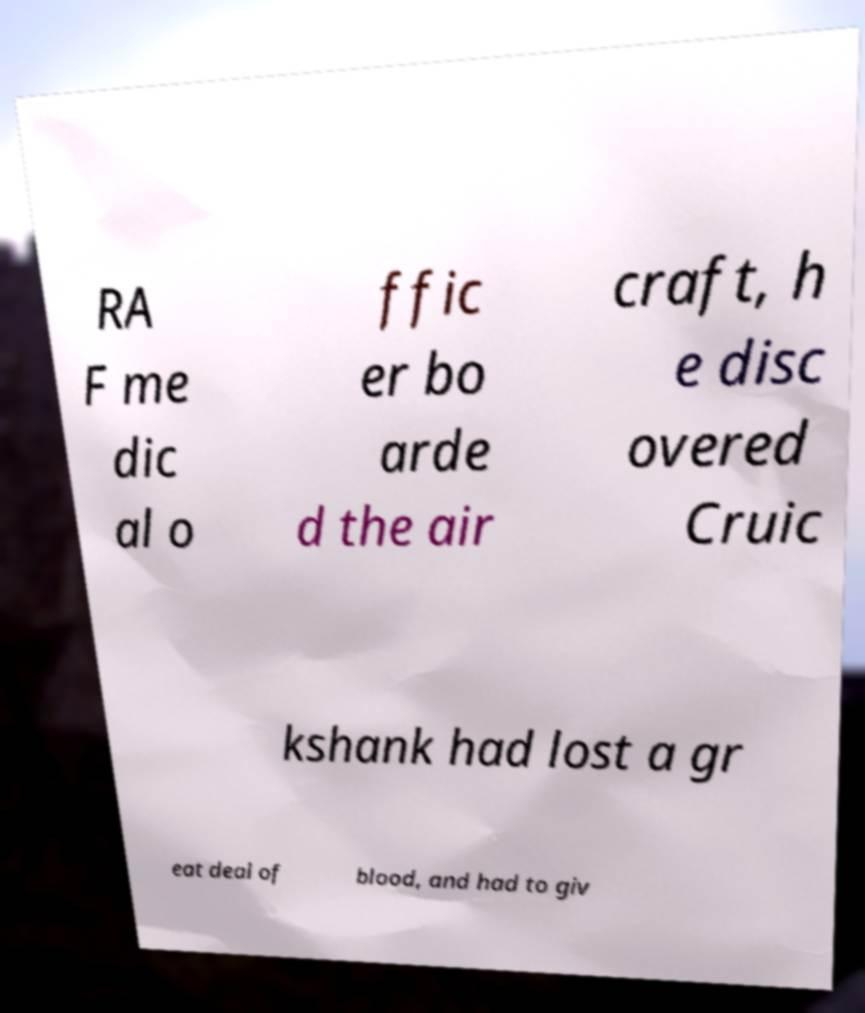I need the written content from this picture converted into text. Can you do that? RA F me dic al o ffic er bo arde d the air craft, h e disc overed Cruic kshank had lost a gr eat deal of blood, and had to giv 